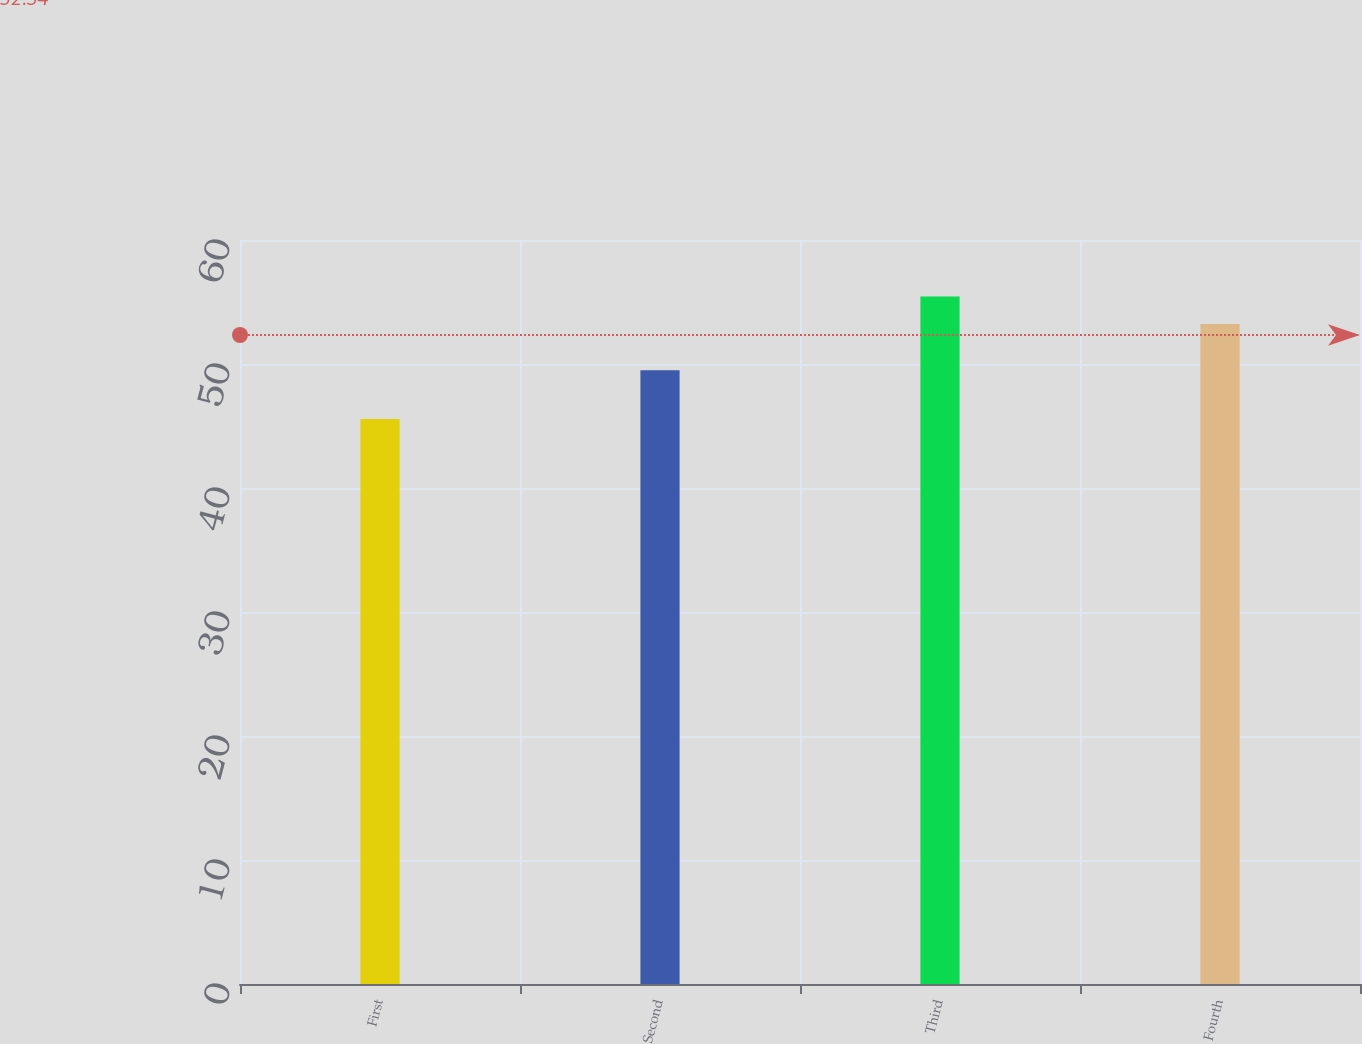Convert chart to OTSL. <chart><loc_0><loc_0><loc_500><loc_500><bar_chart><fcel>First<fcel>Second<fcel>Third<fcel>Fourth<nl><fcel>45.57<fcel>49.49<fcel>55.45<fcel>53.22<nl></chart> 